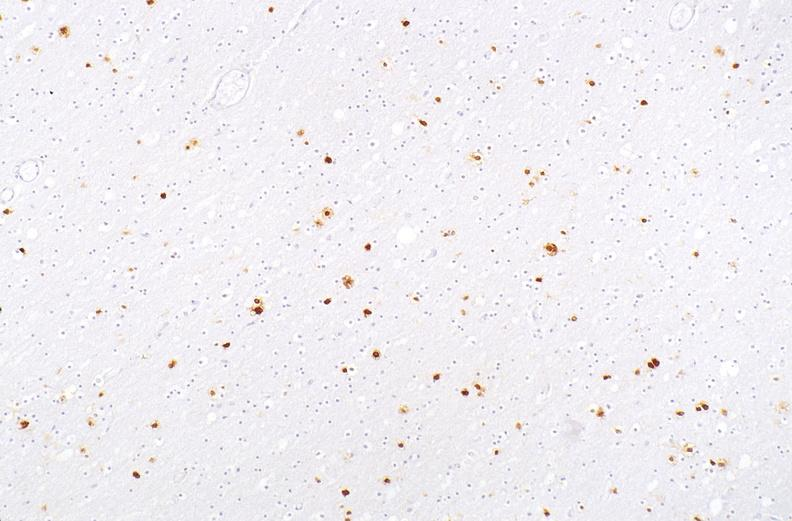does this image show herpes simplex virus, brain, immunohistochemistry?
Answer the question using a single word or phrase. Yes 